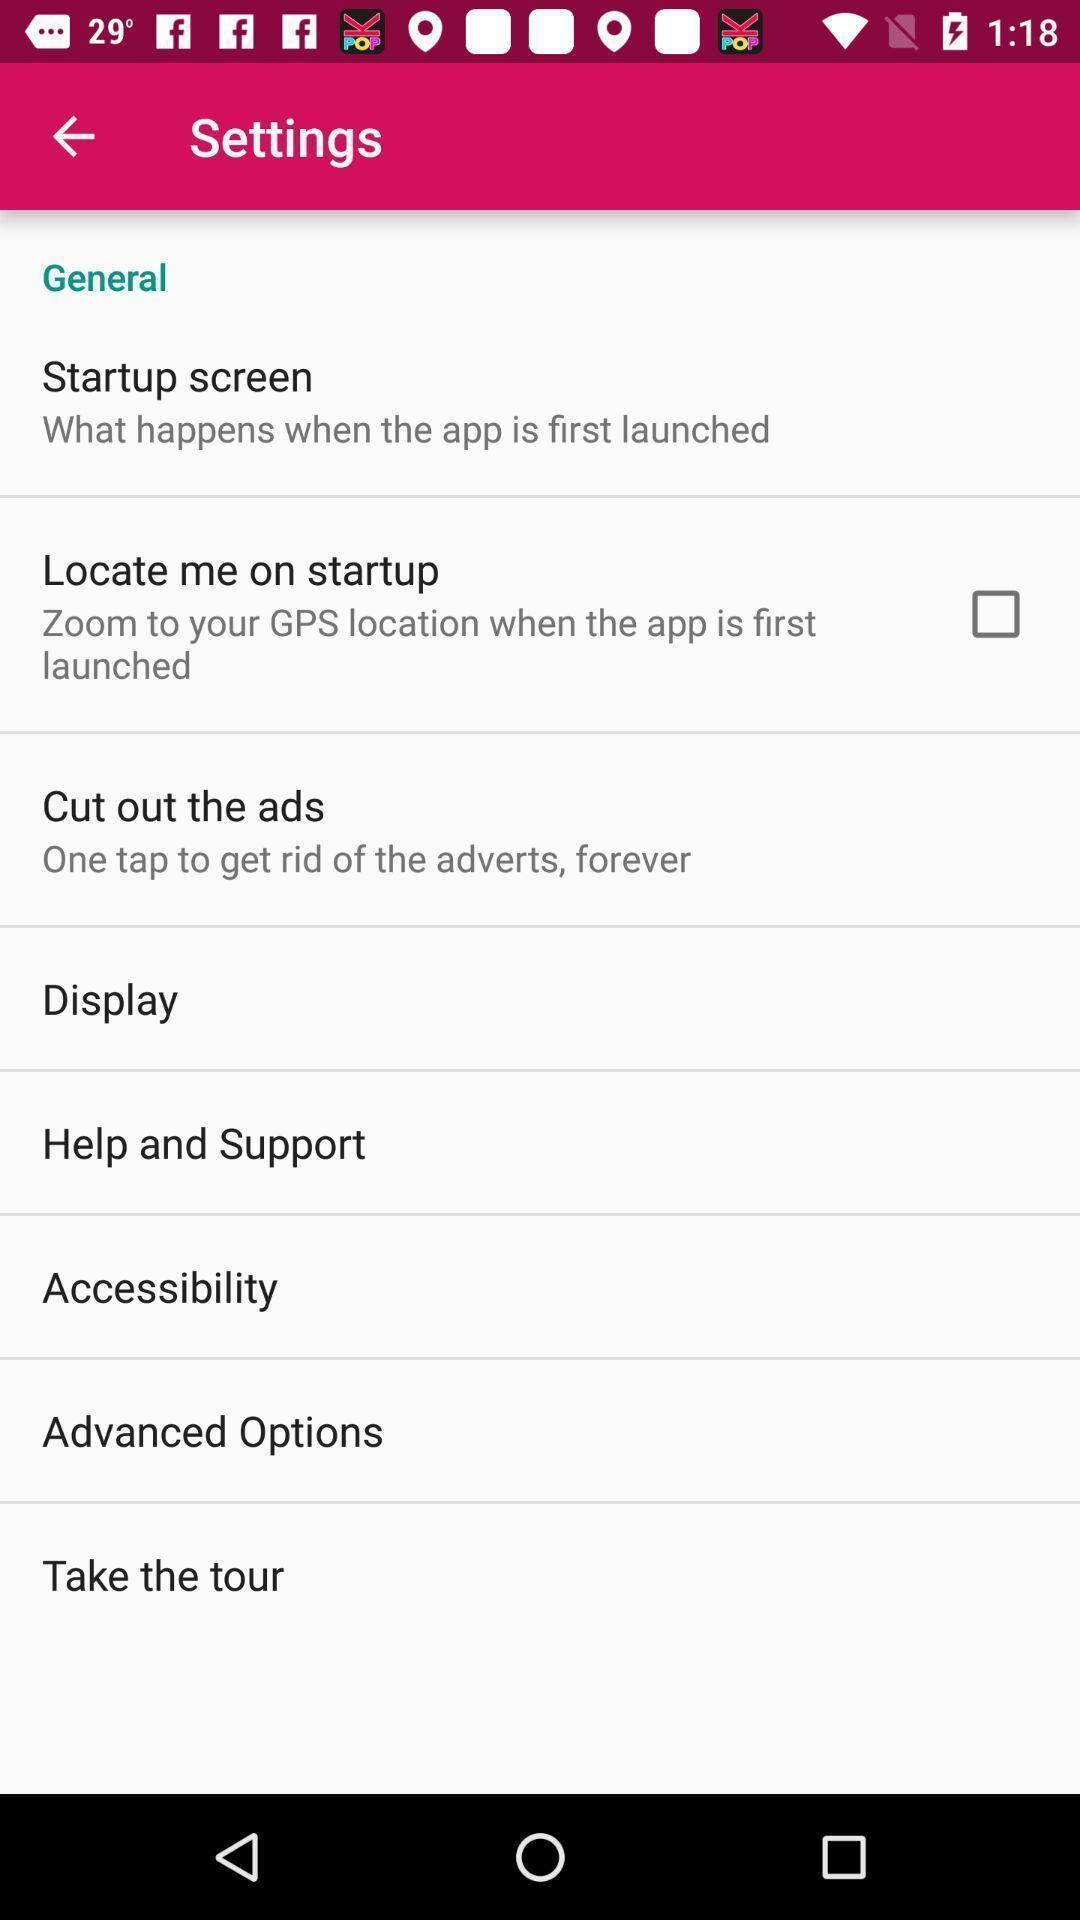Tell me about the visual elements in this screen capture. Settings page. 